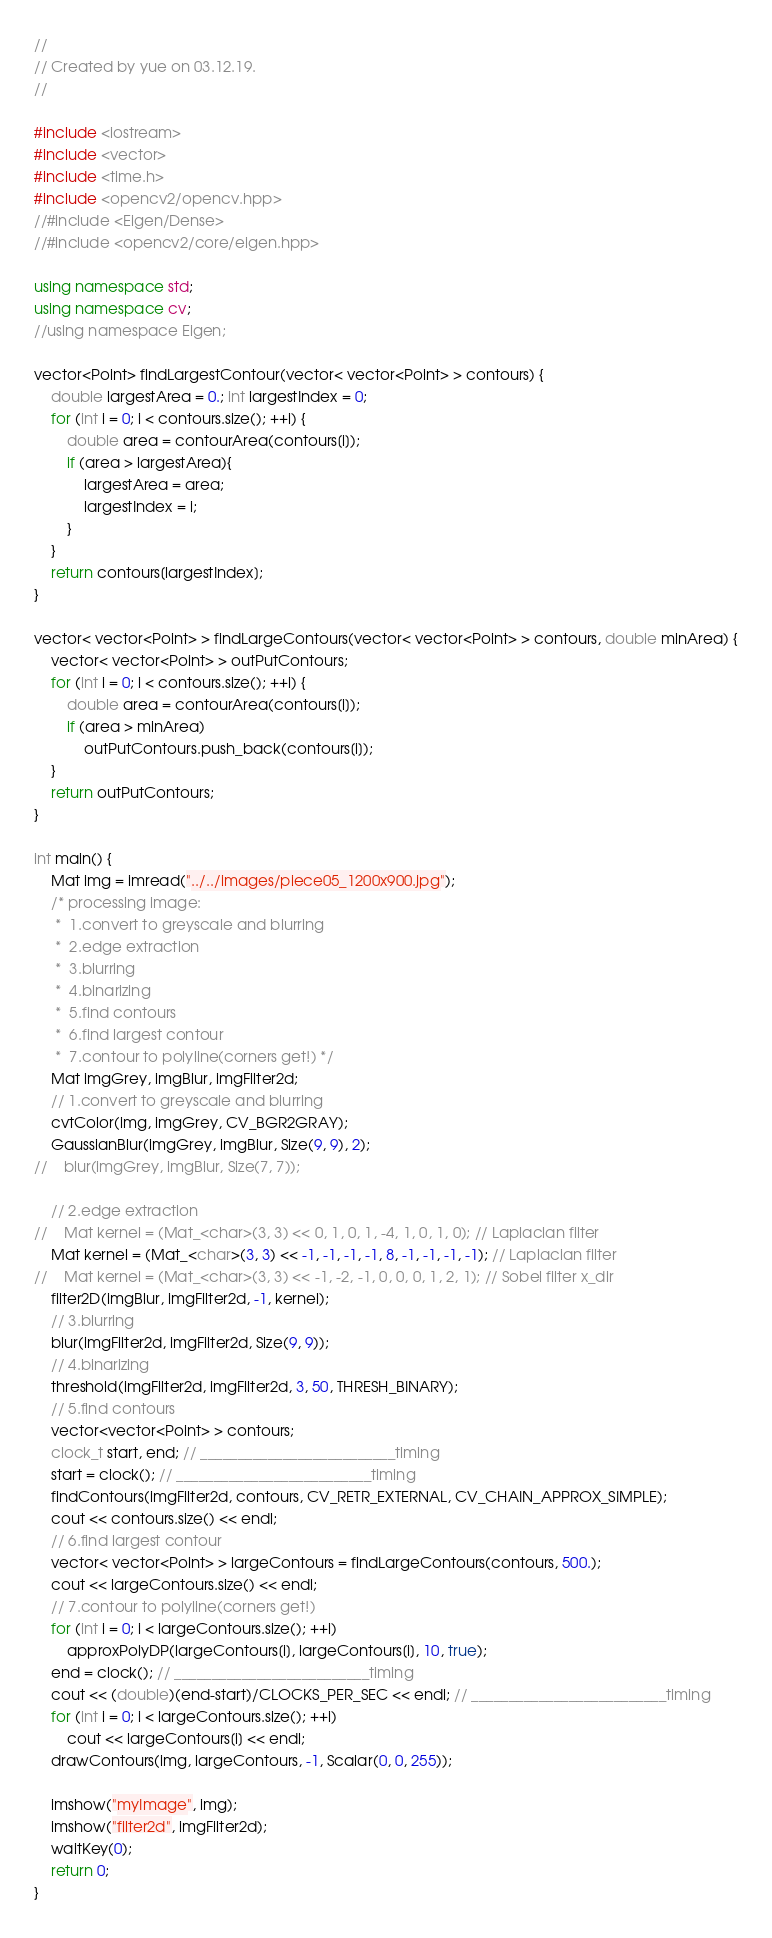Convert code to text. <code><loc_0><loc_0><loc_500><loc_500><_C++_>//
// Created by yue on 03.12.19.
//

#include <iostream>
#include <vector>
#include <time.h>
#include <opencv2/opencv.hpp>
//#include <Eigen/Dense>
//#include <opencv2/core/eigen.hpp>

using namespace std;
using namespace cv;
//using namespace Eigen;

vector<Point> findLargestContour(vector< vector<Point> > contours) {
    double largestArea = 0.; int largestIndex = 0;
    for (int i = 0; i < contours.size(); ++i) {
        double area = contourArea(contours[i]);
        if (area > largestArea){
            largestArea = area;
            largestIndex = i;
        }
    }
    return contours[largestIndex];
}

vector< vector<Point> > findLargeContours(vector< vector<Point> > contours, double minArea) {
    vector< vector<Point> > outPutContours;
    for (int i = 0; i < contours.size(); ++i) {
        double area = contourArea(contours[i]);
        if (area > minArea)
            outPutContours.push_back(contours[i]);
    }
    return outPutContours;
}

int main() {
    Mat img = imread("../../images/piece05_1200x900.jpg");
    /* processing image:
     *  1.convert to greyscale and blurring
     *  2.edge extraction
     *  3.blurring
     *  4.binarizing
     *  5.find contours
     *  6.find largest contour
     *  7.contour to polyline(corners get!) */
    Mat imgGrey, imgBlur, imgFilter2d;
    // 1.convert to greyscale and blurring
    cvtColor(img, imgGrey, CV_BGR2GRAY);
    GaussianBlur(imgGrey, imgBlur, Size(9, 9), 2);
//    blur(imgGrey, imgBlur, Size(7, 7));

    // 2.edge extraction
//    Mat kernel = (Mat_<char>(3, 3) << 0, 1, 0, 1, -4, 1, 0, 1, 0); // Laplacian filter
    Mat kernel = (Mat_<char>(3, 3) << -1, -1, -1, -1, 8, -1, -1, -1, -1); // Laplacian filter
//    Mat kernel = (Mat_<char>(3, 3) << -1, -2, -1, 0, 0, 0, 1, 2, 1); // Sobel filter x_dir
    filter2D(imgBlur, imgFilter2d, -1, kernel);
    // 3.blurring
    blur(imgFilter2d, imgFilter2d, Size(9, 9));
    // 4.binarizing
    threshold(imgFilter2d, imgFilter2d, 3, 50, THRESH_BINARY);
    // 5.find contours
    vector<vector<Point> > contours;
    clock_t start, end; // __________________________timing
    start = clock(); // __________________________timing
    findContours(imgFilter2d, contours, CV_RETR_EXTERNAL, CV_CHAIN_APPROX_SIMPLE);
    cout << contours.size() << endl;
    // 6.find largest contour
    vector< vector<Point> > largeContours = findLargeContours(contours, 500.);
    cout << largeContours.size() << endl;
    // 7.contour to polyline(corners get!)
    for (int i = 0; i < largeContours.size(); ++i)
        approxPolyDP(largeContours[i], largeContours[i], 10, true);
    end = clock(); // __________________________timing
    cout << (double)(end-start)/CLOCKS_PER_SEC << endl; // __________________________timing
    for (int i = 0; i < largeContours.size(); ++i)
        cout << largeContours[i] << endl;
    drawContours(img, largeContours, -1, Scalar(0, 0, 255));

    imshow("myImage", img);
    imshow("filter2d", imgFilter2d);
    waitKey(0);
    return 0;
}
</code> 